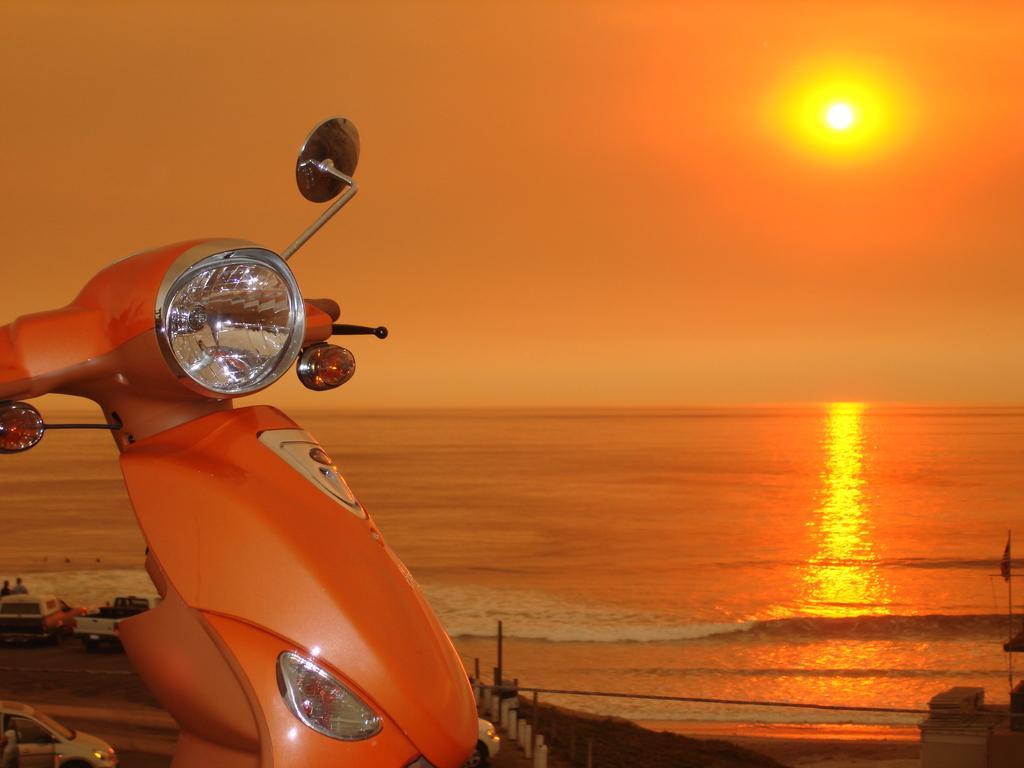How would you summarize this image in a sentence or two? In this picture we can observe an ocean. There is a bike on the left side. In the background there is a sky with a sun. The sky is in orange color. 